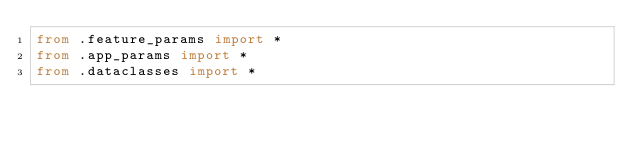<code> <loc_0><loc_0><loc_500><loc_500><_Python_>from .feature_params import *
from .app_params import *
from .dataclasses import *
</code> 